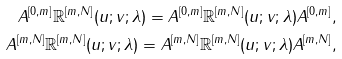Convert formula to latex. <formula><loc_0><loc_0><loc_500><loc_500>A ^ { [ 0 , m ] } \mathbb { R } ^ { [ m , N ] } ( u ; v ; \lambda ) = A ^ { [ 0 , m ] } \mathbb { R } ^ { [ m , N ] } ( u ; v ; \lambda ) A ^ { [ 0 , m ] } , \\ A ^ { [ m , N ] } \mathbb { R } ^ { [ m , N ] } ( u ; v ; \lambda ) = A ^ { [ m , N ] } \mathbb { R } ^ { [ m , N ] } ( u ; v ; \lambda ) A ^ { [ m , N ] } ,</formula> 